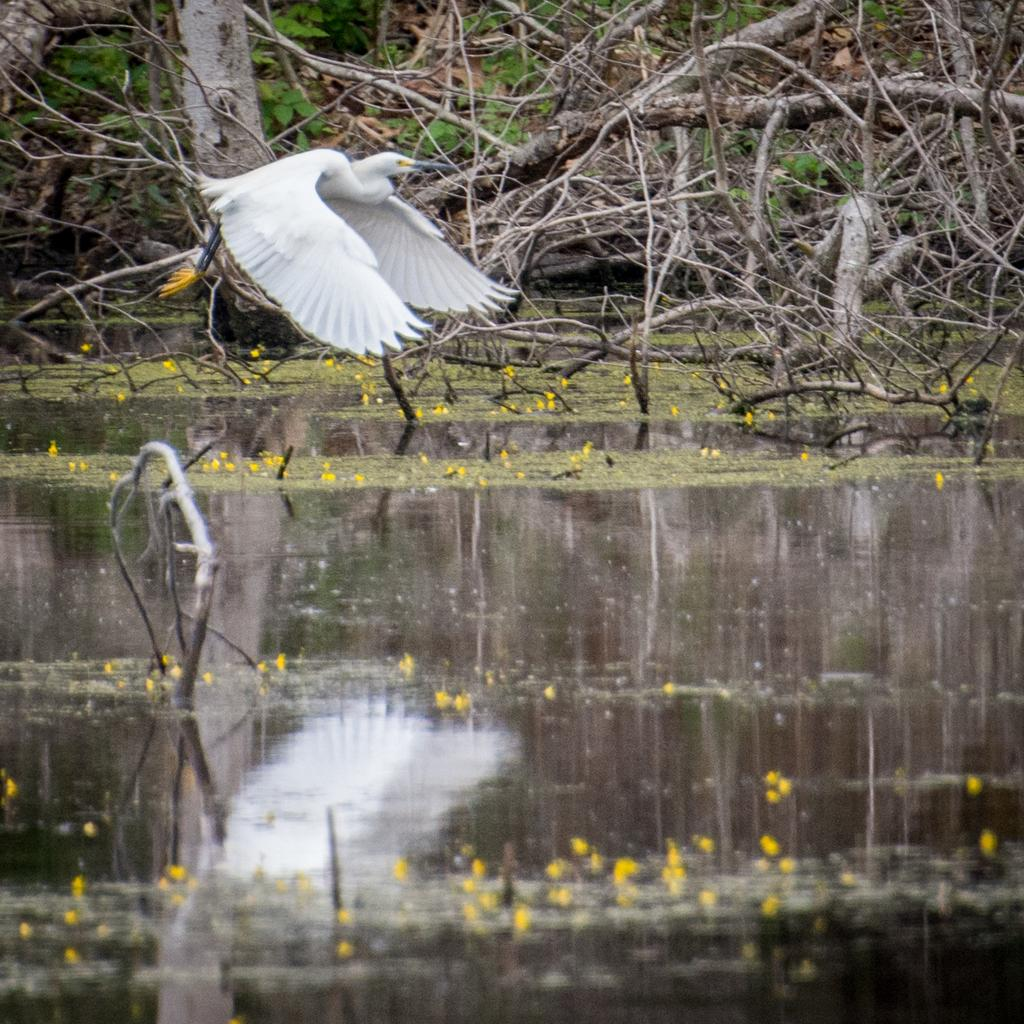What is present at the bottom of the image? There is water at the bottom of the image. What can be seen at the top of the image? There is a bird in a tree at the top of the image. How many lizards are crawling on the quill in the image? There is no quill or lizards present in the image. What type of cork is used to hold the bird in the tree? There is no cork or indication of the bird being held in the tree; it is naturally perched on a branch. 